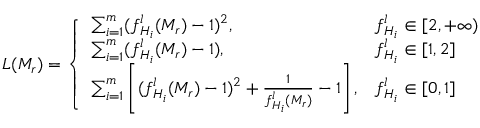<formula> <loc_0><loc_0><loc_500><loc_500>L ( M _ { r } ) = \left \{ \begin{array} { l l } { \sum _ { i = 1 } ^ { m } ( f _ { H _ { i } } ^ { l } ( M _ { r } ) - 1 ) ^ { 2 } , } & { f _ { H _ { i } } ^ { l } \in [ 2 , + \infty ) } \\ { \sum _ { i = 1 } ^ { m } ( f _ { H _ { i } } ^ { l } ( M _ { r } ) - 1 ) , } & { f _ { H _ { i } } ^ { l } \in [ 1 , 2 ] } \\ { \sum _ { i = 1 } ^ { m } \left [ ( f _ { H _ { i } } ^ { l } ( M _ { r } ) - 1 ) ^ { 2 } + \frac { 1 } { f _ { H _ { i } } ^ { l } ( M _ { r } ) } - 1 \right ] , } & { f _ { H _ { i } } ^ { l } \in [ 0 , 1 ] } \end{array}</formula> 